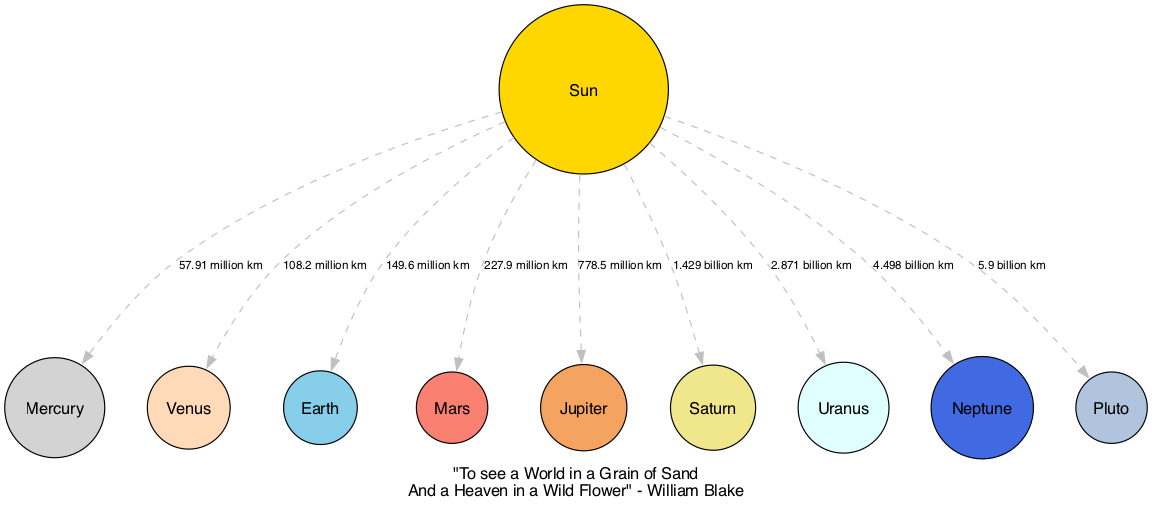What is the distance from the Sun to Mercury? The diagram specifies the distance from the Sun to Mercury as 57.91 million km. This information is displayed along the edge connecting the Sun node and the Mercury node.
Answer: 57.91 million km Which planet is known for its ring system? Saturn is highlighted in the diagram, indicated by its description which includes the fact that it is known for its distinctive ring system. This planet is marked clearly and is the sixth from the Sun.
Answer: Saturn How many planets are there in our solar system according to the diagram? By counting the unique nodes representing planets in the diagram, there are eight recognized planets plus one dwarf planet (Pluto), making a total of nine. This total is derived from the list of nodes provided.
Answer: Nine What is the farthest planet from the Sun based on the diagram? The last node listed after the others is Pluto, which is indicated as the ninth from the Sun. The description and connections make it clear that it is the farthest compared to the other planets.
Answer: Pluto What is the average distance of the gas giants from the Sun? The gas giants in the diagram are Jupiter and Saturn, with Jupiter at 778.5 million km and Saturn at 1.429 billion km. To find the average distance, we add these two distances (778.5 + 1429) and divide by 2, resulting in a numerical value. The calculation yields approximately 1.104 billion km.
Answer: Approximately 1.104 billion km Which planet is closest to Earth? By examining the distances from the Sun, Venus, being the second planet, and Mars, the fourth planet, are both in between Earth and the Sun. The closest in actual distance is Venus (108.2 million km).
Answer: Venus Which planet is named after the Roman god of war? The diagram clearly describes Mars as "associated with the Roman god of war." This is an identifiable characteristic provided in the description under its node.
Answer: Mars What color represents the planet Uranus in the diagram? The color assigned to Uranus in the visual representation is light cyan, which is specified in the color mapping for the planets. This can be inferred from the appearance of the node for Uranus on the diagram.
Answer: Light cyan What literary reference is included in the diagram? The title included at the bottom of the diagram cites William Blake’s quote, “To see a World in a Grain of Sand And a Heaven in a Wild Flower.” This quote is presented as an inspiring subtitle which relates to the vastness depicted in the solar system.
Answer: "To see a World in a Grain of Sand And a Heaven in a Wild Flower" - William Blake 